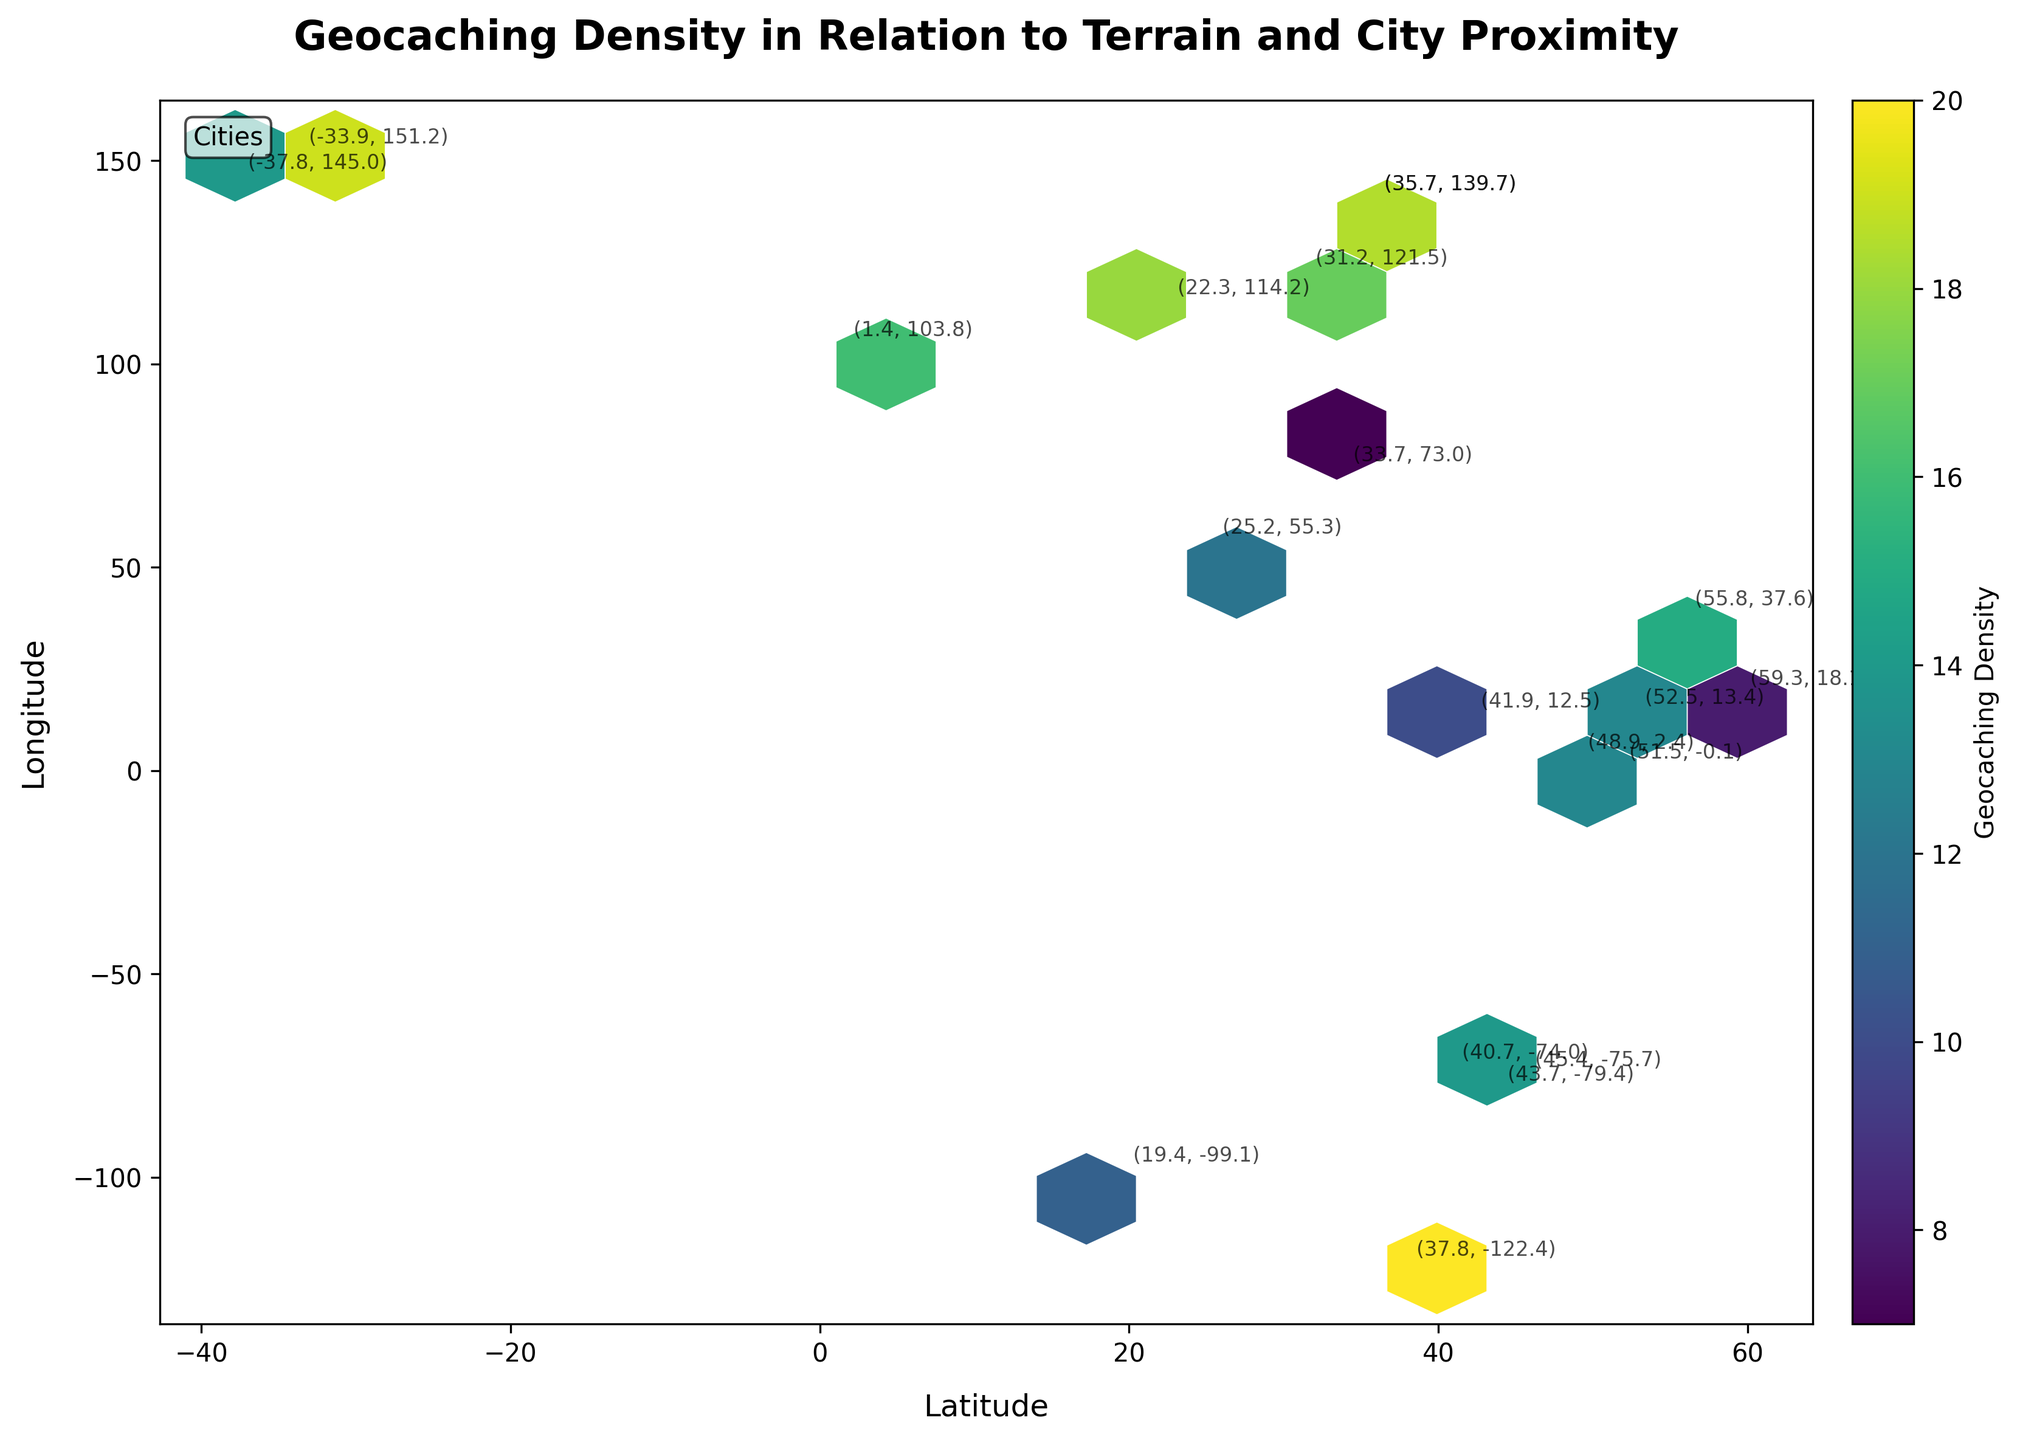What is the title of the plot? The title is located at the top of the plot, typically centered and in a larger font size to distinguish it from other text.
Answer: Geocaching Density in Relation to Terrain and City Proximity What does the color bar represent? The color bar, located on the side of the plot, is labeled "Geocaching Density." It indicates that the colors in the hexbin plot correspond to the density of geocaching locations.
Answer: Geocaching Density How many hexagonal bins do we see in the plot? You can count the individual hexagons that make up the hexbin plot, which are bounded by white edges.
Answer: The exact number varies, but approximately 15x15 grid Which color represents the highest density of geocaching locations? The color map, which is 'viridis,' ranges from purple for low densities to yellow-green for high densities. Look for the lightest color on the plot.
Answer: Yellow-green What are the latitude and longitude ranges shown in the plot? The latitude is on the x-axis and the longitude is on the y-axis. Check the axis limits for both axes to determine the range.
Answer: Latitude: ~(-40 to 60), Longitude: ~(-130 to 150) Are there more geocaching locations in high-density areas or low-density areas? Refer to the color distribution on the hexbin plot. A higher density area will be represented by the yellow-green color, while lower density areas are shown in purple.
Answer: There are more in high-density areas Which city appears to have the highest density of geocaching locations based on the annotations? Look for the city with coordinates (35.7, 139.7) as this location has the highest 'z' value in the provided data.
Answer: Tokyo (35.7, 139.7) How is the density distributed in relation to the major cities and the terrain difficulty? By observing the concentration and colors near the labeled cities, you can infer how terrain difficulty (represented by geocaching density) affects the proximity to these cities.
Answer: Density is generally higher near major city coordinates, with varying values for terrain difficulty What is the difference in geocaching density between Tokyo and New York? The density values for Tokyo and New York are 21 and 18, respectively. Subtract the smaller density from the larger one.
Answer: 3 Which city has a geocaching density closest to the value of 15? Look at the annotations and find the city coordinates where the z-value is closest to 15.
Answer: Toronto (43.7, -79.4) and Moscow (55.8, 37.6) 